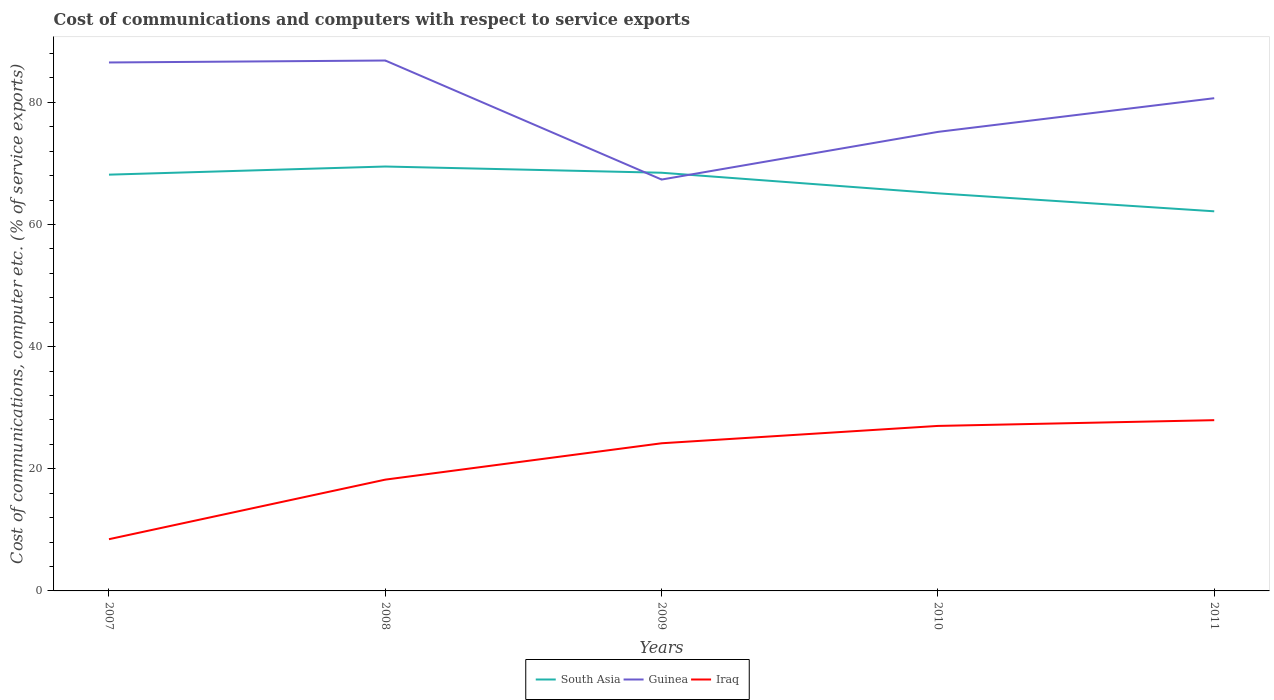How many different coloured lines are there?
Offer a very short reply. 3. Does the line corresponding to South Asia intersect with the line corresponding to Iraq?
Provide a short and direct response. No. Is the number of lines equal to the number of legend labels?
Give a very brief answer. Yes. Across all years, what is the maximum cost of communications and computers in Guinea?
Offer a very short reply. 67.36. In which year was the cost of communications and computers in Iraq maximum?
Your answer should be compact. 2007. What is the total cost of communications and computers in South Asia in the graph?
Keep it short and to the point. -1.33. What is the difference between the highest and the second highest cost of communications and computers in Guinea?
Your answer should be compact. 19.49. Is the cost of communications and computers in Guinea strictly greater than the cost of communications and computers in South Asia over the years?
Your answer should be very brief. No. How many lines are there?
Offer a very short reply. 3. How many years are there in the graph?
Your answer should be very brief. 5. Are the values on the major ticks of Y-axis written in scientific E-notation?
Your answer should be very brief. No. Does the graph contain grids?
Give a very brief answer. No. How many legend labels are there?
Provide a short and direct response. 3. What is the title of the graph?
Your response must be concise. Cost of communications and computers with respect to service exports. What is the label or title of the Y-axis?
Offer a terse response. Cost of communications, computer etc. (% of service exports). What is the Cost of communications, computer etc. (% of service exports) of South Asia in 2007?
Your answer should be very brief. 68.16. What is the Cost of communications, computer etc. (% of service exports) in Guinea in 2007?
Keep it short and to the point. 86.53. What is the Cost of communications, computer etc. (% of service exports) in Iraq in 2007?
Your answer should be very brief. 8.47. What is the Cost of communications, computer etc. (% of service exports) of South Asia in 2008?
Ensure brevity in your answer.  69.49. What is the Cost of communications, computer etc. (% of service exports) of Guinea in 2008?
Ensure brevity in your answer.  86.85. What is the Cost of communications, computer etc. (% of service exports) of Iraq in 2008?
Your response must be concise. 18.22. What is the Cost of communications, computer etc. (% of service exports) in South Asia in 2009?
Your response must be concise. 68.47. What is the Cost of communications, computer etc. (% of service exports) in Guinea in 2009?
Keep it short and to the point. 67.36. What is the Cost of communications, computer etc. (% of service exports) of Iraq in 2009?
Make the answer very short. 24.18. What is the Cost of communications, computer etc. (% of service exports) in South Asia in 2010?
Your answer should be compact. 65.1. What is the Cost of communications, computer etc. (% of service exports) in Guinea in 2010?
Offer a very short reply. 75.16. What is the Cost of communications, computer etc. (% of service exports) of Iraq in 2010?
Give a very brief answer. 27.02. What is the Cost of communications, computer etc. (% of service exports) in South Asia in 2011?
Ensure brevity in your answer.  62.16. What is the Cost of communications, computer etc. (% of service exports) in Guinea in 2011?
Keep it short and to the point. 80.68. What is the Cost of communications, computer etc. (% of service exports) in Iraq in 2011?
Make the answer very short. 27.96. Across all years, what is the maximum Cost of communications, computer etc. (% of service exports) in South Asia?
Provide a succinct answer. 69.49. Across all years, what is the maximum Cost of communications, computer etc. (% of service exports) in Guinea?
Offer a terse response. 86.85. Across all years, what is the maximum Cost of communications, computer etc. (% of service exports) of Iraq?
Ensure brevity in your answer.  27.96. Across all years, what is the minimum Cost of communications, computer etc. (% of service exports) of South Asia?
Provide a short and direct response. 62.16. Across all years, what is the minimum Cost of communications, computer etc. (% of service exports) of Guinea?
Your response must be concise. 67.36. Across all years, what is the minimum Cost of communications, computer etc. (% of service exports) in Iraq?
Offer a very short reply. 8.47. What is the total Cost of communications, computer etc. (% of service exports) in South Asia in the graph?
Give a very brief answer. 333.39. What is the total Cost of communications, computer etc. (% of service exports) in Guinea in the graph?
Offer a very short reply. 396.58. What is the total Cost of communications, computer etc. (% of service exports) of Iraq in the graph?
Give a very brief answer. 105.85. What is the difference between the Cost of communications, computer etc. (% of service exports) of South Asia in 2007 and that in 2008?
Provide a short and direct response. -1.33. What is the difference between the Cost of communications, computer etc. (% of service exports) in Guinea in 2007 and that in 2008?
Provide a short and direct response. -0.32. What is the difference between the Cost of communications, computer etc. (% of service exports) of Iraq in 2007 and that in 2008?
Provide a succinct answer. -9.76. What is the difference between the Cost of communications, computer etc. (% of service exports) in South Asia in 2007 and that in 2009?
Give a very brief answer. -0.31. What is the difference between the Cost of communications, computer etc. (% of service exports) of Guinea in 2007 and that in 2009?
Your answer should be compact. 19.17. What is the difference between the Cost of communications, computer etc. (% of service exports) of Iraq in 2007 and that in 2009?
Provide a succinct answer. -15.71. What is the difference between the Cost of communications, computer etc. (% of service exports) in South Asia in 2007 and that in 2010?
Offer a terse response. 3.06. What is the difference between the Cost of communications, computer etc. (% of service exports) in Guinea in 2007 and that in 2010?
Provide a succinct answer. 11.37. What is the difference between the Cost of communications, computer etc. (% of service exports) of Iraq in 2007 and that in 2010?
Your response must be concise. -18.55. What is the difference between the Cost of communications, computer etc. (% of service exports) in South Asia in 2007 and that in 2011?
Offer a terse response. 6. What is the difference between the Cost of communications, computer etc. (% of service exports) of Guinea in 2007 and that in 2011?
Give a very brief answer. 5.85. What is the difference between the Cost of communications, computer etc. (% of service exports) of Iraq in 2007 and that in 2011?
Offer a terse response. -19.49. What is the difference between the Cost of communications, computer etc. (% of service exports) in South Asia in 2008 and that in 2009?
Offer a terse response. 1.02. What is the difference between the Cost of communications, computer etc. (% of service exports) in Guinea in 2008 and that in 2009?
Offer a terse response. 19.49. What is the difference between the Cost of communications, computer etc. (% of service exports) in Iraq in 2008 and that in 2009?
Ensure brevity in your answer.  -5.95. What is the difference between the Cost of communications, computer etc. (% of service exports) of South Asia in 2008 and that in 2010?
Keep it short and to the point. 4.39. What is the difference between the Cost of communications, computer etc. (% of service exports) in Guinea in 2008 and that in 2010?
Your answer should be very brief. 11.69. What is the difference between the Cost of communications, computer etc. (% of service exports) in Iraq in 2008 and that in 2010?
Provide a short and direct response. -8.79. What is the difference between the Cost of communications, computer etc. (% of service exports) of South Asia in 2008 and that in 2011?
Ensure brevity in your answer.  7.34. What is the difference between the Cost of communications, computer etc. (% of service exports) of Guinea in 2008 and that in 2011?
Offer a terse response. 6.17. What is the difference between the Cost of communications, computer etc. (% of service exports) of Iraq in 2008 and that in 2011?
Your response must be concise. -9.74. What is the difference between the Cost of communications, computer etc. (% of service exports) in South Asia in 2009 and that in 2010?
Your answer should be compact. 3.37. What is the difference between the Cost of communications, computer etc. (% of service exports) of Guinea in 2009 and that in 2010?
Offer a very short reply. -7.81. What is the difference between the Cost of communications, computer etc. (% of service exports) in Iraq in 2009 and that in 2010?
Keep it short and to the point. -2.84. What is the difference between the Cost of communications, computer etc. (% of service exports) of South Asia in 2009 and that in 2011?
Your answer should be compact. 6.31. What is the difference between the Cost of communications, computer etc. (% of service exports) in Guinea in 2009 and that in 2011?
Provide a succinct answer. -13.32. What is the difference between the Cost of communications, computer etc. (% of service exports) of Iraq in 2009 and that in 2011?
Your answer should be very brief. -3.78. What is the difference between the Cost of communications, computer etc. (% of service exports) in South Asia in 2010 and that in 2011?
Keep it short and to the point. 2.94. What is the difference between the Cost of communications, computer etc. (% of service exports) of Guinea in 2010 and that in 2011?
Give a very brief answer. -5.52. What is the difference between the Cost of communications, computer etc. (% of service exports) of Iraq in 2010 and that in 2011?
Make the answer very short. -0.94. What is the difference between the Cost of communications, computer etc. (% of service exports) in South Asia in 2007 and the Cost of communications, computer etc. (% of service exports) in Guinea in 2008?
Give a very brief answer. -18.69. What is the difference between the Cost of communications, computer etc. (% of service exports) of South Asia in 2007 and the Cost of communications, computer etc. (% of service exports) of Iraq in 2008?
Offer a terse response. 49.94. What is the difference between the Cost of communications, computer etc. (% of service exports) of Guinea in 2007 and the Cost of communications, computer etc. (% of service exports) of Iraq in 2008?
Make the answer very short. 68.31. What is the difference between the Cost of communications, computer etc. (% of service exports) of South Asia in 2007 and the Cost of communications, computer etc. (% of service exports) of Guinea in 2009?
Give a very brief answer. 0.8. What is the difference between the Cost of communications, computer etc. (% of service exports) in South Asia in 2007 and the Cost of communications, computer etc. (% of service exports) in Iraq in 2009?
Offer a very short reply. 43.98. What is the difference between the Cost of communications, computer etc. (% of service exports) of Guinea in 2007 and the Cost of communications, computer etc. (% of service exports) of Iraq in 2009?
Keep it short and to the point. 62.35. What is the difference between the Cost of communications, computer etc. (% of service exports) of South Asia in 2007 and the Cost of communications, computer etc. (% of service exports) of Guinea in 2010?
Your answer should be very brief. -7. What is the difference between the Cost of communications, computer etc. (% of service exports) of South Asia in 2007 and the Cost of communications, computer etc. (% of service exports) of Iraq in 2010?
Your answer should be compact. 41.14. What is the difference between the Cost of communications, computer etc. (% of service exports) of Guinea in 2007 and the Cost of communications, computer etc. (% of service exports) of Iraq in 2010?
Your answer should be very brief. 59.51. What is the difference between the Cost of communications, computer etc. (% of service exports) of South Asia in 2007 and the Cost of communications, computer etc. (% of service exports) of Guinea in 2011?
Your answer should be very brief. -12.52. What is the difference between the Cost of communications, computer etc. (% of service exports) of South Asia in 2007 and the Cost of communications, computer etc. (% of service exports) of Iraq in 2011?
Give a very brief answer. 40.2. What is the difference between the Cost of communications, computer etc. (% of service exports) in Guinea in 2007 and the Cost of communications, computer etc. (% of service exports) in Iraq in 2011?
Your response must be concise. 58.57. What is the difference between the Cost of communications, computer etc. (% of service exports) in South Asia in 2008 and the Cost of communications, computer etc. (% of service exports) in Guinea in 2009?
Offer a very short reply. 2.14. What is the difference between the Cost of communications, computer etc. (% of service exports) in South Asia in 2008 and the Cost of communications, computer etc. (% of service exports) in Iraq in 2009?
Your answer should be compact. 45.32. What is the difference between the Cost of communications, computer etc. (% of service exports) of Guinea in 2008 and the Cost of communications, computer etc. (% of service exports) of Iraq in 2009?
Offer a very short reply. 62.67. What is the difference between the Cost of communications, computer etc. (% of service exports) in South Asia in 2008 and the Cost of communications, computer etc. (% of service exports) in Guinea in 2010?
Offer a very short reply. -5.67. What is the difference between the Cost of communications, computer etc. (% of service exports) of South Asia in 2008 and the Cost of communications, computer etc. (% of service exports) of Iraq in 2010?
Your answer should be compact. 42.48. What is the difference between the Cost of communications, computer etc. (% of service exports) in Guinea in 2008 and the Cost of communications, computer etc. (% of service exports) in Iraq in 2010?
Provide a short and direct response. 59.83. What is the difference between the Cost of communications, computer etc. (% of service exports) in South Asia in 2008 and the Cost of communications, computer etc. (% of service exports) in Guinea in 2011?
Make the answer very short. -11.19. What is the difference between the Cost of communications, computer etc. (% of service exports) in South Asia in 2008 and the Cost of communications, computer etc. (% of service exports) in Iraq in 2011?
Your answer should be very brief. 41.54. What is the difference between the Cost of communications, computer etc. (% of service exports) of Guinea in 2008 and the Cost of communications, computer etc. (% of service exports) of Iraq in 2011?
Give a very brief answer. 58.89. What is the difference between the Cost of communications, computer etc. (% of service exports) in South Asia in 2009 and the Cost of communications, computer etc. (% of service exports) in Guinea in 2010?
Your answer should be very brief. -6.69. What is the difference between the Cost of communications, computer etc. (% of service exports) of South Asia in 2009 and the Cost of communications, computer etc. (% of service exports) of Iraq in 2010?
Provide a short and direct response. 41.46. What is the difference between the Cost of communications, computer etc. (% of service exports) of Guinea in 2009 and the Cost of communications, computer etc. (% of service exports) of Iraq in 2010?
Provide a short and direct response. 40.34. What is the difference between the Cost of communications, computer etc. (% of service exports) of South Asia in 2009 and the Cost of communications, computer etc. (% of service exports) of Guinea in 2011?
Give a very brief answer. -12.21. What is the difference between the Cost of communications, computer etc. (% of service exports) of South Asia in 2009 and the Cost of communications, computer etc. (% of service exports) of Iraq in 2011?
Provide a short and direct response. 40.52. What is the difference between the Cost of communications, computer etc. (% of service exports) of Guinea in 2009 and the Cost of communications, computer etc. (% of service exports) of Iraq in 2011?
Provide a succinct answer. 39.4. What is the difference between the Cost of communications, computer etc. (% of service exports) in South Asia in 2010 and the Cost of communications, computer etc. (% of service exports) in Guinea in 2011?
Offer a very short reply. -15.58. What is the difference between the Cost of communications, computer etc. (% of service exports) of South Asia in 2010 and the Cost of communications, computer etc. (% of service exports) of Iraq in 2011?
Keep it short and to the point. 37.15. What is the difference between the Cost of communications, computer etc. (% of service exports) in Guinea in 2010 and the Cost of communications, computer etc. (% of service exports) in Iraq in 2011?
Your answer should be compact. 47.21. What is the average Cost of communications, computer etc. (% of service exports) in South Asia per year?
Offer a very short reply. 66.68. What is the average Cost of communications, computer etc. (% of service exports) in Guinea per year?
Provide a succinct answer. 79.32. What is the average Cost of communications, computer etc. (% of service exports) in Iraq per year?
Make the answer very short. 21.17. In the year 2007, what is the difference between the Cost of communications, computer etc. (% of service exports) in South Asia and Cost of communications, computer etc. (% of service exports) in Guinea?
Offer a terse response. -18.37. In the year 2007, what is the difference between the Cost of communications, computer etc. (% of service exports) of South Asia and Cost of communications, computer etc. (% of service exports) of Iraq?
Your answer should be compact. 59.69. In the year 2007, what is the difference between the Cost of communications, computer etc. (% of service exports) of Guinea and Cost of communications, computer etc. (% of service exports) of Iraq?
Give a very brief answer. 78.06. In the year 2008, what is the difference between the Cost of communications, computer etc. (% of service exports) of South Asia and Cost of communications, computer etc. (% of service exports) of Guinea?
Offer a terse response. -17.36. In the year 2008, what is the difference between the Cost of communications, computer etc. (% of service exports) in South Asia and Cost of communications, computer etc. (% of service exports) in Iraq?
Your response must be concise. 51.27. In the year 2008, what is the difference between the Cost of communications, computer etc. (% of service exports) of Guinea and Cost of communications, computer etc. (% of service exports) of Iraq?
Provide a short and direct response. 68.63. In the year 2009, what is the difference between the Cost of communications, computer etc. (% of service exports) in South Asia and Cost of communications, computer etc. (% of service exports) in Guinea?
Offer a very short reply. 1.12. In the year 2009, what is the difference between the Cost of communications, computer etc. (% of service exports) of South Asia and Cost of communications, computer etc. (% of service exports) of Iraq?
Give a very brief answer. 44.3. In the year 2009, what is the difference between the Cost of communications, computer etc. (% of service exports) in Guinea and Cost of communications, computer etc. (% of service exports) in Iraq?
Your answer should be compact. 43.18. In the year 2010, what is the difference between the Cost of communications, computer etc. (% of service exports) of South Asia and Cost of communications, computer etc. (% of service exports) of Guinea?
Offer a very short reply. -10.06. In the year 2010, what is the difference between the Cost of communications, computer etc. (% of service exports) of South Asia and Cost of communications, computer etc. (% of service exports) of Iraq?
Provide a short and direct response. 38.09. In the year 2010, what is the difference between the Cost of communications, computer etc. (% of service exports) in Guinea and Cost of communications, computer etc. (% of service exports) in Iraq?
Provide a succinct answer. 48.15. In the year 2011, what is the difference between the Cost of communications, computer etc. (% of service exports) of South Asia and Cost of communications, computer etc. (% of service exports) of Guinea?
Provide a succinct answer. -18.52. In the year 2011, what is the difference between the Cost of communications, computer etc. (% of service exports) of South Asia and Cost of communications, computer etc. (% of service exports) of Iraq?
Keep it short and to the point. 34.2. In the year 2011, what is the difference between the Cost of communications, computer etc. (% of service exports) in Guinea and Cost of communications, computer etc. (% of service exports) in Iraq?
Your answer should be very brief. 52.72. What is the ratio of the Cost of communications, computer etc. (% of service exports) in South Asia in 2007 to that in 2008?
Provide a succinct answer. 0.98. What is the ratio of the Cost of communications, computer etc. (% of service exports) in Guinea in 2007 to that in 2008?
Your answer should be very brief. 1. What is the ratio of the Cost of communications, computer etc. (% of service exports) of Iraq in 2007 to that in 2008?
Provide a succinct answer. 0.46. What is the ratio of the Cost of communications, computer etc. (% of service exports) of Guinea in 2007 to that in 2009?
Ensure brevity in your answer.  1.28. What is the ratio of the Cost of communications, computer etc. (% of service exports) in Iraq in 2007 to that in 2009?
Give a very brief answer. 0.35. What is the ratio of the Cost of communications, computer etc. (% of service exports) of South Asia in 2007 to that in 2010?
Your answer should be very brief. 1.05. What is the ratio of the Cost of communications, computer etc. (% of service exports) of Guinea in 2007 to that in 2010?
Your answer should be compact. 1.15. What is the ratio of the Cost of communications, computer etc. (% of service exports) in Iraq in 2007 to that in 2010?
Your answer should be compact. 0.31. What is the ratio of the Cost of communications, computer etc. (% of service exports) of South Asia in 2007 to that in 2011?
Give a very brief answer. 1.1. What is the ratio of the Cost of communications, computer etc. (% of service exports) of Guinea in 2007 to that in 2011?
Give a very brief answer. 1.07. What is the ratio of the Cost of communications, computer etc. (% of service exports) of Iraq in 2007 to that in 2011?
Offer a very short reply. 0.3. What is the ratio of the Cost of communications, computer etc. (% of service exports) of South Asia in 2008 to that in 2009?
Your response must be concise. 1.01. What is the ratio of the Cost of communications, computer etc. (% of service exports) of Guinea in 2008 to that in 2009?
Make the answer very short. 1.29. What is the ratio of the Cost of communications, computer etc. (% of service exports) in Iraq in 2008 to that in 2009?
Offer a very short reply. 0.75. What is the ratio of the Cost of communications, computer etc. (% of service exports) of South Asia in 2008 to that in 2010?
Give a very brief answer. 1.07. What is the ratio of the Cost of communications, computer etc. (% of service exports) in Guinea in 2008 to that in 2010?
Your answer should be compact. 1.16. What is the ratio of the Cost of communications, computer etc. (% of service exports) in Iraq in 2008 to that in 2010?
Keep it short and to the point. 0.67. What is the ratio of the Cost of communications, computer etc. (% of service exports) of South Asia in 2008 to that in 2011?
Provide a succinct answer. 1.12. What is the ratio of the Cost of communications, computer etc. (% of service exports) in Guinea in 2008 to that in 2011?
Give a very brief answer. 1.08. What is the ratio of the Cost of communications, computer etc. (% of service exports) of Iraq in 2008 to that in 2011?
Keep it short and to the point. 0.65. What is the ratio of the Cost of communications, computer etc. (% of service exports) in South Asia in 2009 to that in 2010?
Your answer should be compact. 1.05. What is the ratio of the Cost of communications, computer etc. (% of service exports) of Guinea in 2009 to that in 2010?
Your answer should be compact. 0.9. What is the ratio of the Cost of communications, computer etc. (% of service exports) of Iraq in 2009 to that in 2010?
Make the answer very short. 0.89. What is the ratio of the Cost of communications, computer etc. (% of service exports) of South Asia in 2009 to that in 2011?
Keep it short and to the point. 1.1. What is the ratio of the Cost of communications, computer etc. (% of service exports) in Guinea in 2009 to that in 2011?
Provide a short and direct response. 0.83. What is the ratio of the Cost of communications, computer etc. (% of service exports) of Iraq in 2009 to that in 2011?
Ensure brevity in your answer.  0.86. What is the ratio of the Cost of communications, computer etc. (% of service exports) in South Asia in 2010 to that in 2011?
Offer a terse response. 1.05. What is the ratio of the Cost of communications, computer etc. (% of service exports) in Guinea in 2010 to that in 2011?
Your answer should be compact. 0.93. What is the ratio of the Cost of communications, computer etc. (% of service exports) of Iraq in 2010 to that in 2011?
Make the answer very short. 0.97. What is the difference between the highest and the second highest Cost of communications, computer etc. (% of service exports) in South Asia?
Offer a very short reply. 1.02. What is the difference between the highest and the second highest Cost of communications, computer etc. (% of service exports) in Guinea?
Your answer should be compact. 0.32. What is the difference between the highest and the second highest Cost of communications, computer etc. (% of service exports) of Iraq?
Your response must be concise. 0.94. What is the difference between the highest and the lowest Cost of communications, computer etc. (% of service exports) in South Asia?
Your answer should be compact. 7.34. What is the difference between the highest and the lowest Cost of communications, computer etc. (% of service exports) of Guinea?
Provide a succinct answer. 19.49. What is the difference between the highest and the lowest Cost of communications, computer etc. (% of service exports) in Iraq?
Provide a short and direct response. 19.49. 